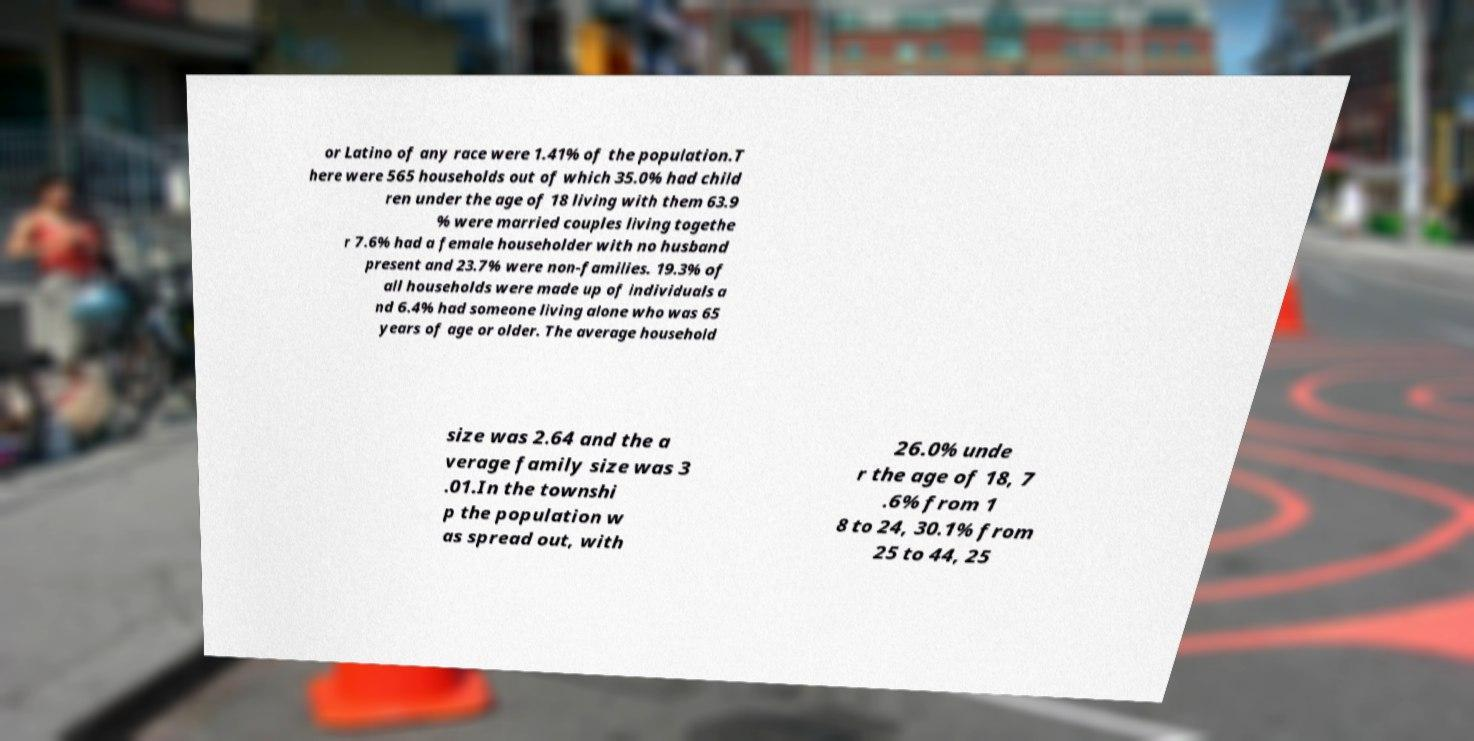I need the written content from this picture converted into text. Can you do that? or Latino of any race were 1.41% of the population.T here were 565 households out of which 35.0% had child ren under the age of 18 living with them 63.9 % were married couples living togethe r 7.6% had a female householder with no husband present and 23.7% were non-families. 19.3% of all households were made up of individuals a nd 6.4% had someone living alone who was 65 years of age or older. The average household size was 2.64 and the a verage family size was 3 .01.In the townshi p the population w as spread out, with 26.0% unde r the age of 18, 7 .6% from 1 8 to 24, 30.1% from 25 to 44, 25 